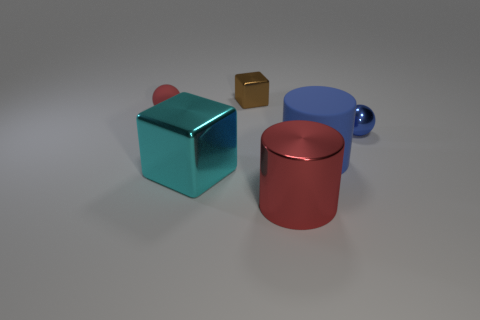Add 1 brown blocks. How many objects exist? 7 Subtract all cylinders. How many objects are left? 4 Subtract 0 green blocks. How many objects are left? 6 Subtract all large red things. Subtract all big things. How many objects are left? 2 Add 3 large metal cylinders. How many large metal cylinders are left? 4 Add 6 big red cylinders. How many big red cylinders exist? 7 